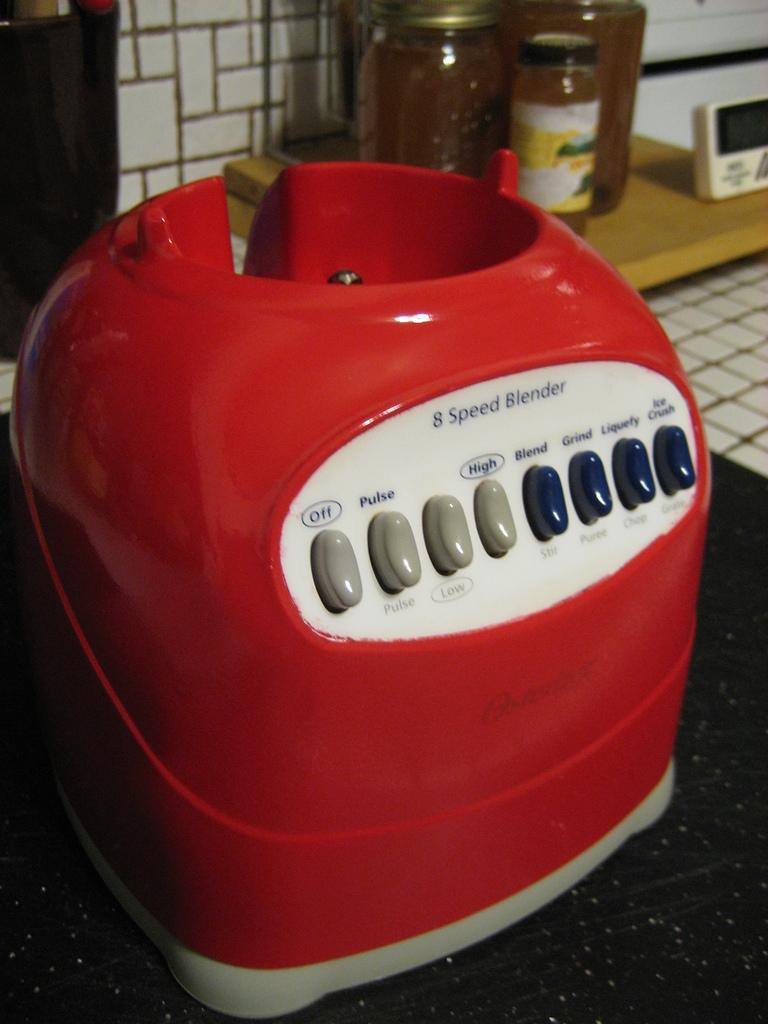<image>
Create a compact narrative representing the image presented. The red base to an 8 apeed blender. 